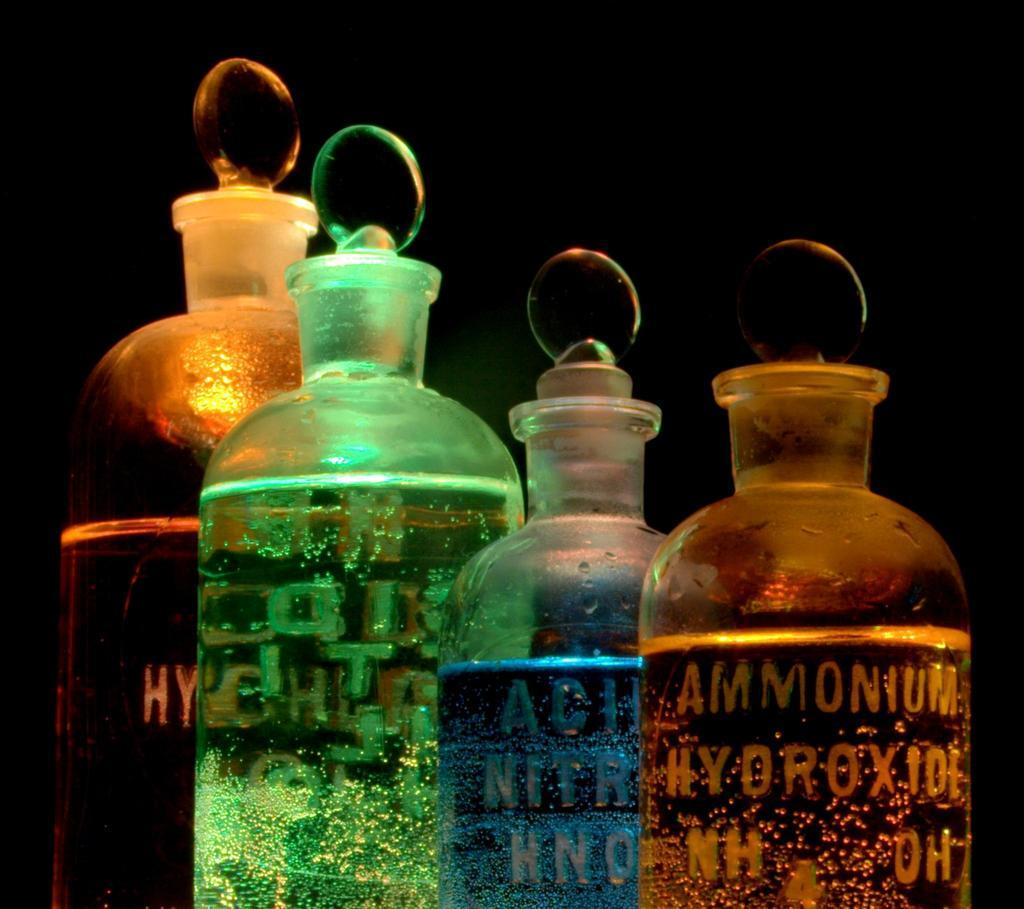<image>
Present a compact description of the photo's key features. Four colourful bottles of chemicals are seen against a black background, one bottle contains Ammonium Hydroxide. 